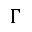Convert formula to latex. <formula><loc_0><loc_0><loc_500><loc_500>\Gamma</formula> 